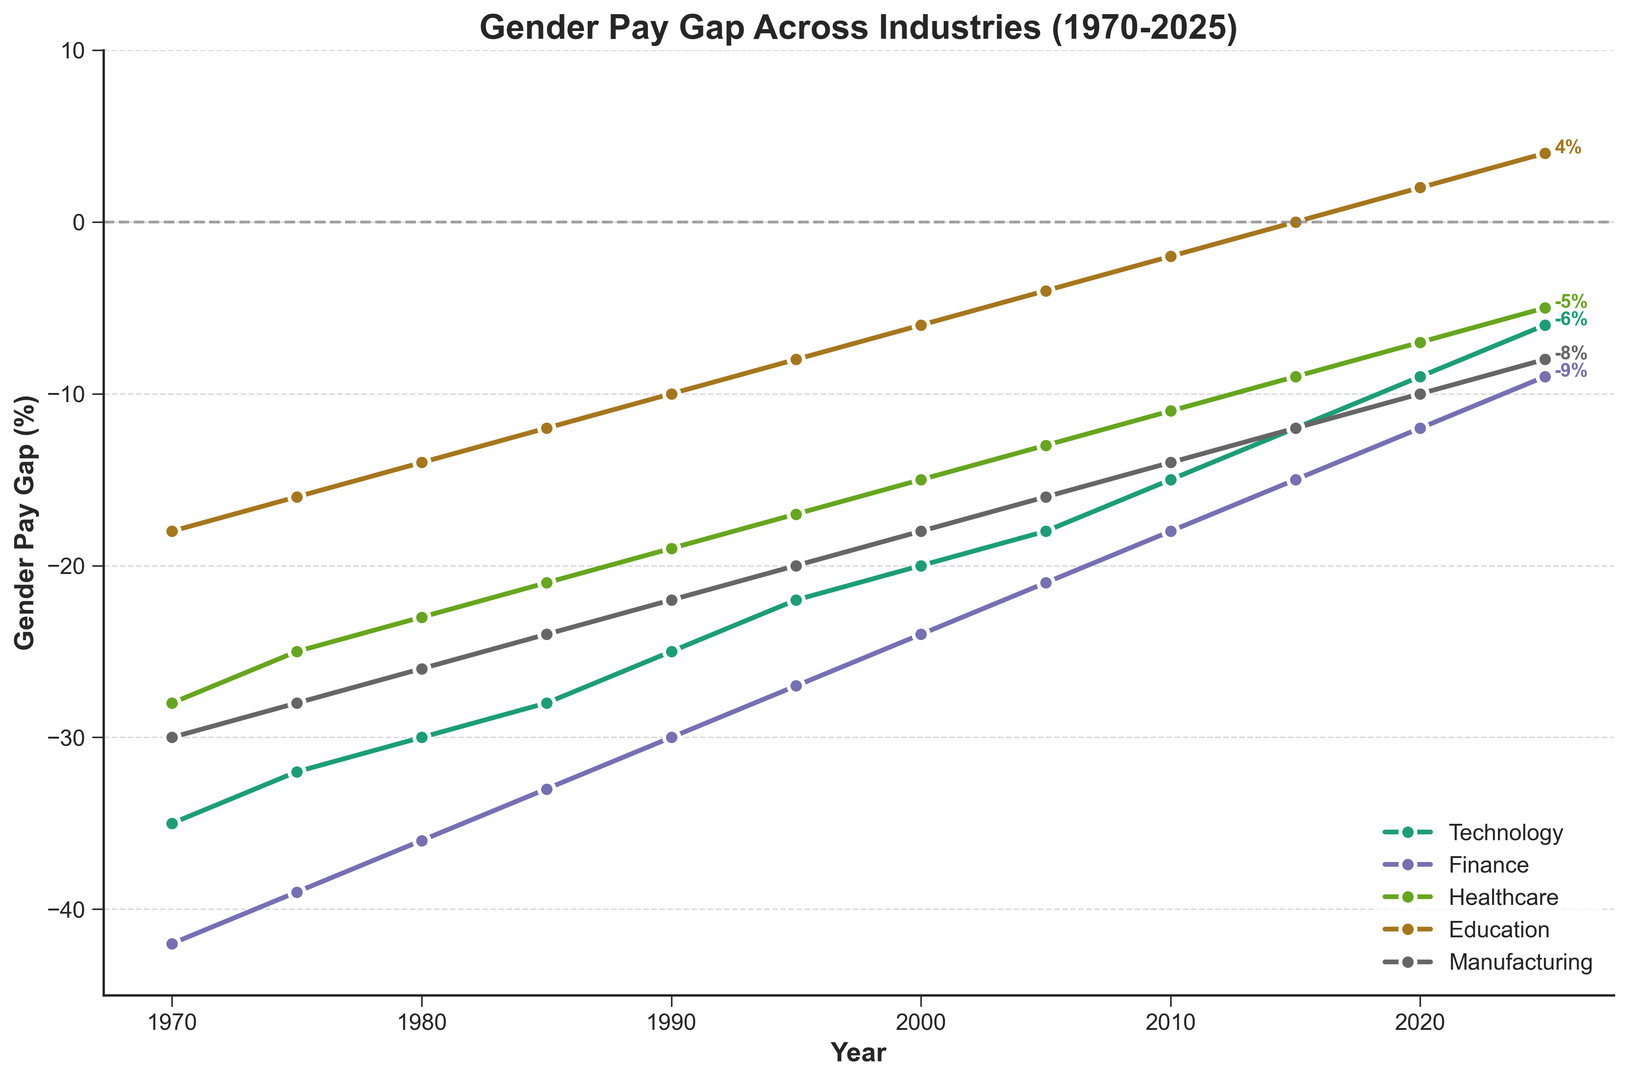What is the trend for the gender pay gap in the Finance industry from 1970 to 2025? The trend shows a consistent decrease in the pay gap, starting from -42% in 1970, moving towards -9% in 2025.
Answer: Consistently decreasing In which year did the Education industry achieve a positive gender pay gap? According to the figure, the positive gender pay gap in the Education industry began in 2015, starting at 0% and increasing to 4% by 2025.
Answer: 2015 Which industry had the highest gender pay gap in 1970, and what was the percentage? In 1970, the Finance industry had the highest gender pay gap, with a rate of -42%.
Answer: Finance, -42% Compare the gender pay gap reduction from 1970 to 2025 in Healthcare and Manufacturing industries. Which industry shows a greater improvement? In Healthcare, the gap reduced from -28% to -5%, a change of 23 percentage points. In Manufacturing, it reduced from -30% to -8%, a change of 22 percentage points. Hence, Healthcare shows a slightly greater improvement.
Answer: Healthcare What is the current (2025) gender pay gap in Technology compared to Healthcare? In 2025, the Technology industry has a gender pay gap of -6%, while Healthcare has a gap of -5%. The gap is slightly higher in Technology.
Answer: Technology -6%, Healthcare -5% What is the average gender pay gap across all industries in 1980? The gender pay gaps for 1980 are Technology: -30%, Finance: -36%, Healthcare: -23%, Education: -14%, Manufacturing: -26%. Sum these up to get (-30 - 36 - 23 - 14 - 26) = -129. The average is -129/5 = -25.8%.
Answer: -25.8% In which decade did the Technology industry experience the most significant reduction in the gender pay gap? By examining the trends, the steepest reduction occurred between 2010 and 2020, where the gap reduced from -15% to -9%, a 6 percentage points improvement.
Answer: 2010-2020 Which two industries have the same gender pay gap in 2020, and what is that value? Both Technology and Healthcare industries have a gender pay gap of -7% in 2020.
Answer: Technology and Healthcare, -7% Between which consecutive years does the Education industry show the most significant positive change? The Education industry shows a significant positive change between 2010 and 2015, where the gap goes from -2% to 0%, marking the shift from negative to zero.
Answer: 2010-2015 